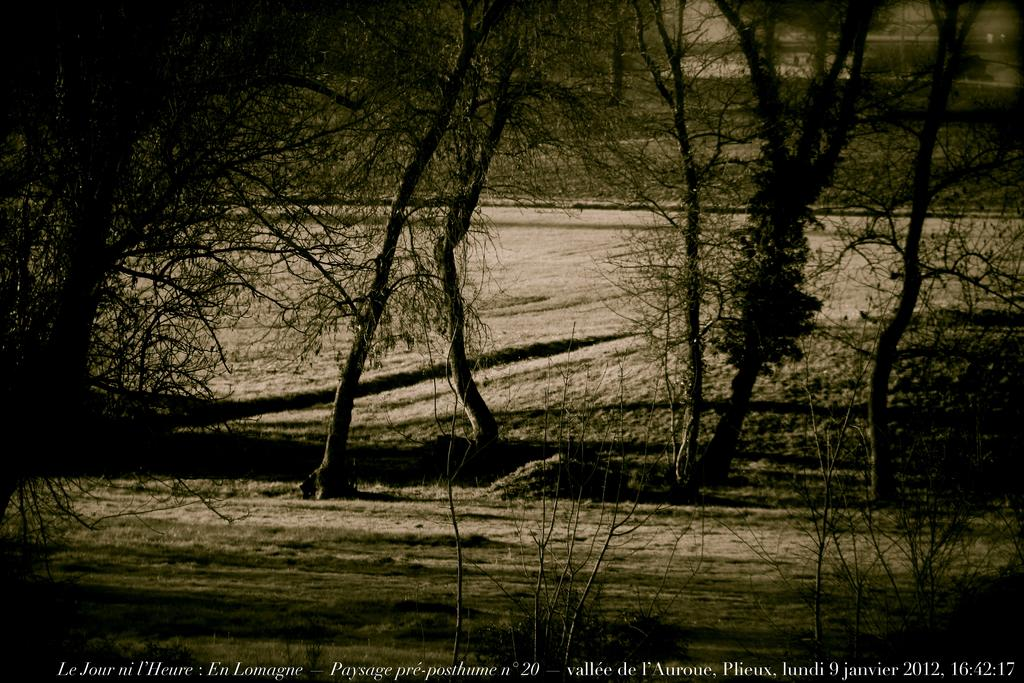What type of vegetation is present in the image? There is grass and trees in the image. Can you describe the natural environment depicted in the image? The image features grass and trees, suggesting a natural outdoor setting. Is there any indication of the image's origin or ownership? Yes, there is a watermark on the image. How many ants can be seen crawling on the sheet in the image? There are no ants or sheets present in the image; it features grass and trees. 